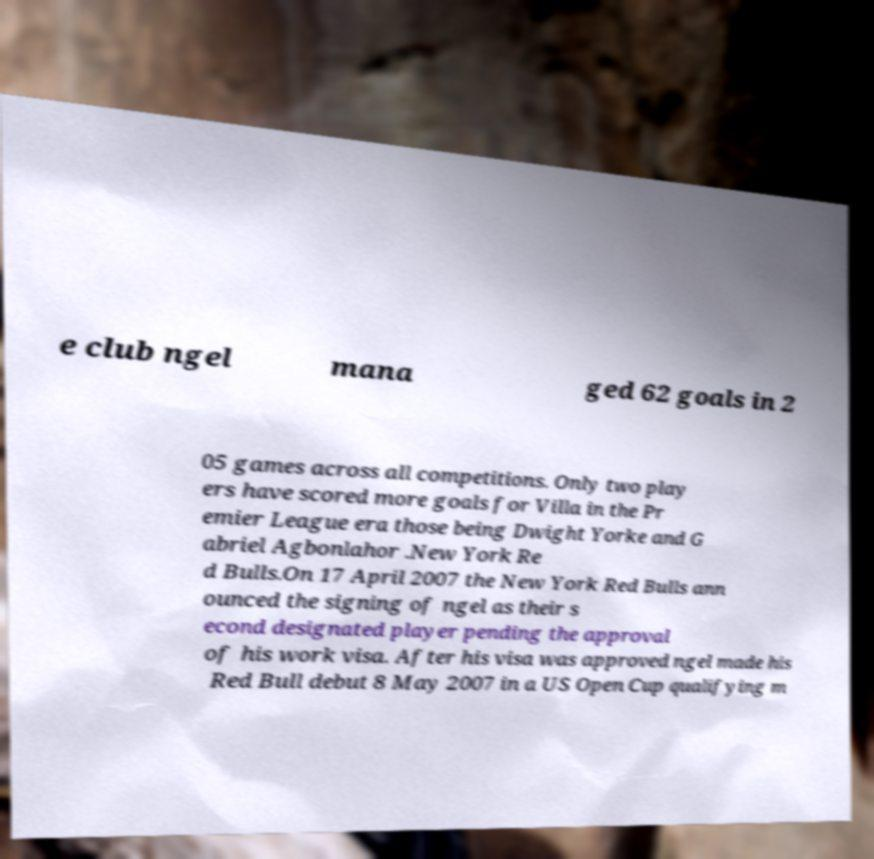Can you read and provide the text displayed in the image?This photo seems to have some interesting text. Can you extract and type it out for me? e club ngel mana ged 62 goals in 2 05 games across all competitions. Only two play ers have scored more goals for Villa in the Pr emier League era those being Dwight Yorke and G abriel Agbonlahor .New York Re d Bulls.On 17 April 2007 the New York Red Bulls ann ounced the signing of ngel as their s econd designated player pending the approval of his work visa. After his visa was approved ngel made his Red Bull debut 8 May 2007 in a US Open Cup qualifying m 